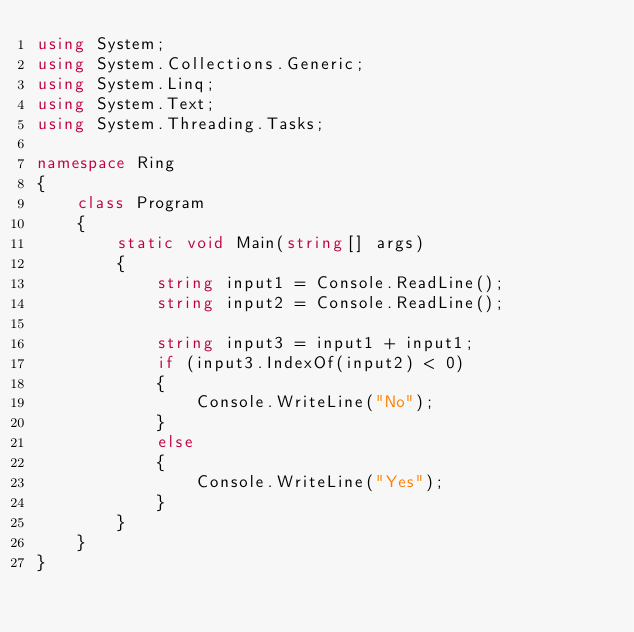Convert code to text. <code><loc_0><loc_0><loc_500><loc_500><_C#_>using System;
using System.Collections.Generic;
using System.Linq;
using System.Text;
using System.Threading.Tasks;

namespace Ring
{
    class Program
    {
        static void Main(string[] args)
        {
            string input1 = Console.ReadLine();
            string input2 = Console.ReadLine();

            string input3 = input1 + input1;
            if (input3.IndexOf(input2) < 0)
            {
                Console.WriteLine("No");
            }
            else
            {
                Console.WriteLine("Yes");
            }
        }
    }
}

</code> 